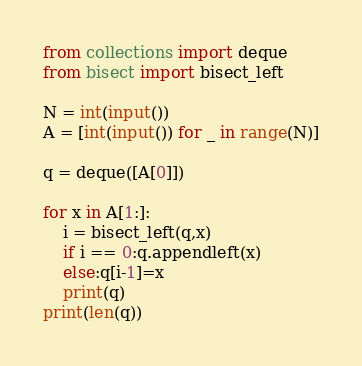<code> <loc_0><loc_0><loc_500><loc_500><_Python_>from collections import deque
from bisect import bisect_left

N = int(input())
A = [int(input()) for _ in range(N)]

q = deque([A[0]])

for x in A[1:]:
    i = bisect_left(q,x)
    if i == 0:q.appendleft(x)
    else:q[i-1]=x
    print(q)
print(len(q))
</code> 